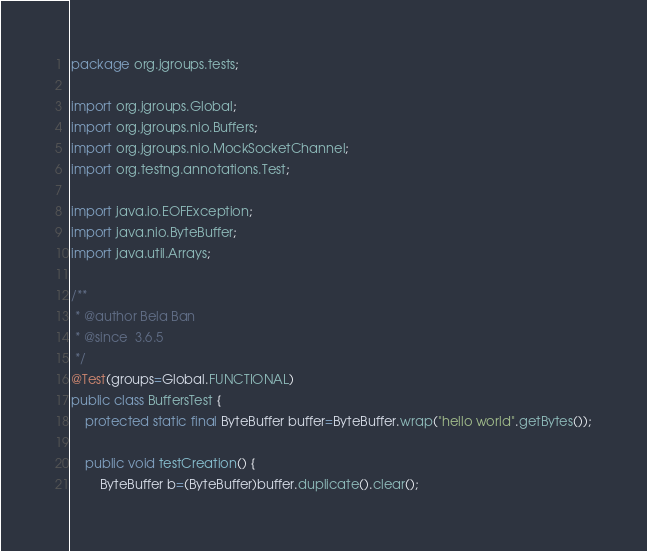<code> <loc_0><loc_0><loc_500><loc_500><_Java_>package org.jgroups.tests;

import org.jgroups.Global;
import org.jgroups.nio.Buffers;
import org.jgroups.nio.MockSocketChannel;
import org.testng.annotations.Test;

import java.io.EOFException;
import java.nio.ByteBuffer;
import java.util.Arrays;

/**
 * @author Bela Ban
 * @since  3.6.5
 */
@Test(groups=Global.FUNCTIONAL)
public class BuffersTest {
    protected static final ByteBuffer buffer=ByteBuffer.wrap("hello world".getBytes());

    public void testCreation() {
        ByteBuffer b=(ByteBuffer)buffer.duplicate().clear();</code> 